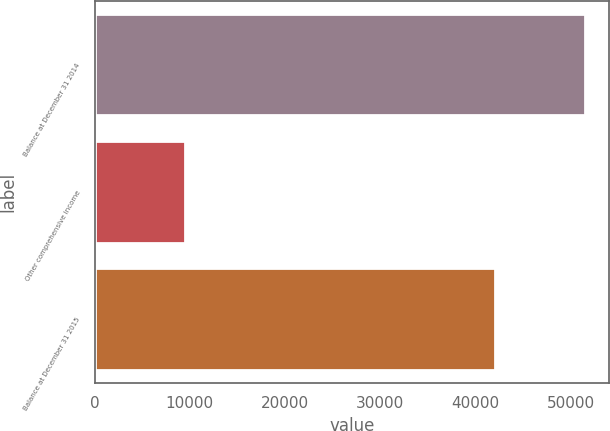<chart> <loc_0><loc_0><loc_500><loc_500><bar_chart><fcel>Balance at December 31 2014<fcel>Other comprehensive income<fcel>Balance at December 31 2015<nl><fcel>51452<fcel>9441<fcel>42011<nl></chart> 